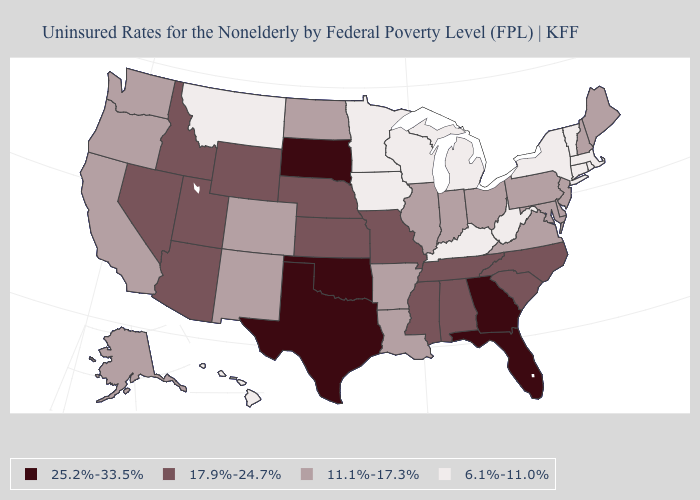Does the first symbol in the legend represent the smallest category?
Quick response, please. No. What is the value of Mississippi?
Keep it brief. 17.9%-24.7%. Among the states that border Virginia , which have the lowest value?
Give a very brief answer. Kentucky, West Virginia. Name the states that have a value in the range 25.2%-33.5%?
Keep it brief. Florida, Georgia, Oklahoma, South Dakota, Texas. What is the highest value in states that border Texas?
Keep it brief. 25.2%-33.5%. Name the states that have a value in the range 25.2%-33.5%?
Give a very brief answer. Florida, Georgia, Oklahoma, South Dakota, Texas. What is the value of Tennessee?
Concise answer only. 17.9%-24.7%. Does Arizona have the lowest value in the West?
Short answer required. No. What is the value of Washington?
Short answer required. 11.1%-17.3%. What is the value of Oregon?
Keep it brief. 11.1%-17.3%. What is the value of New York?
Keep it brief. 6.1%-11.0%. What is the value of Alabama?
Quick response, please. 17.9%-24.7%. Among the states that border Ohio , which have the lowest value?
Give a very brief answer. Kentucky, Michigan, West Virginia. Name the states that have a value in the range 25.2%-33.5%?
Concise answer only. Florida, Georgia, Oklahoma, South Dakota, Texas. 